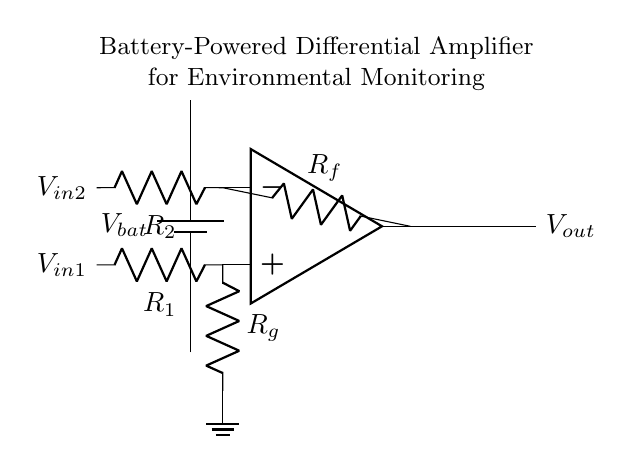What is the type of amplifier shown in the circuit? The circuit consists of a differential amplifier, which is specifically designed to amplify the difference between two input voltages. This can be inferred from the configuration that includes both inverting and non-inverting inputs.
Answer: differential amplifier What powers the circuit? The circuit is powered by a battery, as indicated by the battery symbol at the left side of the diagram. A battery provides the necessary voltage for the operation of the amplifier.
Answer: battery What are the input voltages of the amplifier? The input voltages are labeled as V-in1 and V-in2 on the diagram, representing the two individual input signals that the differential amplifier processes.
Answer: V-in1 and V-in2 How many resistors are used in the feedback section? There are two resistors in the feedback section of the amplifier: R-f and R-g. These resistors are part of the configuration that sets the gain of the amplifier.
Answer: two What is the output voltage represented as in the circuit? The output voltage is represented as V-out, shown on the right side of the amplifier. This is the result of the amplification process based on the input voltages and the feedback resistors.
Answer: V-out Why are there two different input resistors in the circuit? The presence of two different input resistors, R-1 and R-2, allows for different scaling of the input signals, which is essential to achieve the differential amplification required for accurate measurement and environmental monitoring.
Answer: for scaling input signals What does R-f control in the amplifier? Resistor R-f controls the feedback mechanism and, consequently, the gain of the differential amplifier, affecting how much of the output is fed back to the input for amplification.
Answer: feedback gain 